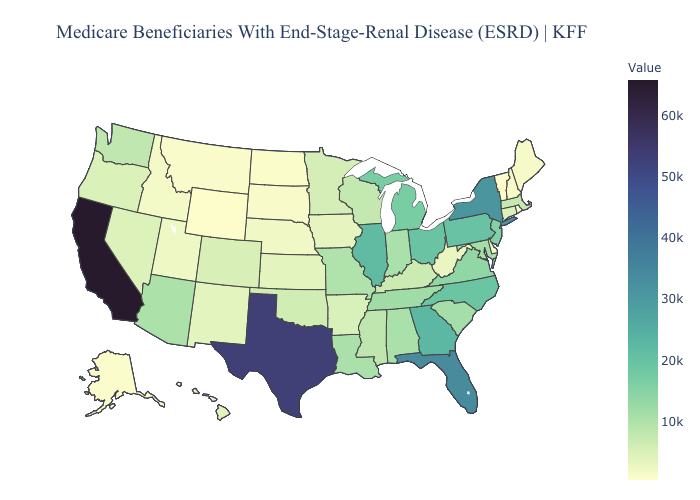Does Minnesota have a lower value than Texas?
Be succinct. Yes. Which states have the highest value in the USA?
Write a very short answer. California. Does California have the highest value in the USA?
Quick response, please. Yes. Among the states that border Arkansas , does Oklahoma have the lowest value?
Concise answer only. Yes. 